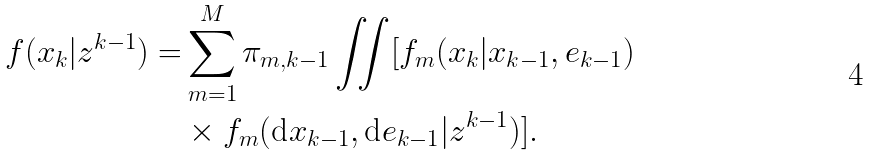Convert formula to latex. <formula><loc_0><loc_0><loc_500><loc_500>f ( x _ { k } | z ^ { k - 1 } ) = & \sum _ { m = 1 } ^ { M } \pi _ { m , k - 1 } \iint [ f _ { m } ( x _ { k } | x _ { k - 1 } , e _ { k - 1 } ) \\ & \times f _ { m } ( \text {d} x _ { k - 1 } , \text {d} e _ { k - 1 } | z ^ { k - 1 } ) ] .</formula> 